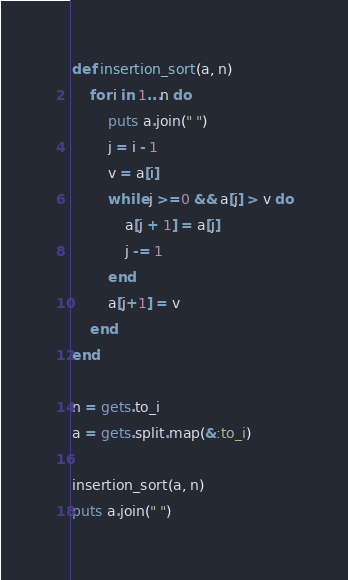<code> <loc_0><loc_0><loc_500><loc_500><_Ruby_>def insertion_sort(a, n)
    for i in 1...n do
        puts a.join(" ")
        j = i - 1
        v = a[i]
        while j >=0 && a[j] > v do
            a[j + 1] = a[j]
            j -= 1
        end
        a[j+1] = v
    end
end

n = gets.to_i
a = gets.split.map(&:to_i)

insertion_sort(a, n)
puts a.join(" ")
</code> 